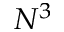<formula> <loc_0><loc_0><loc_500><loc_500>N ^ { 3 }</formula> 